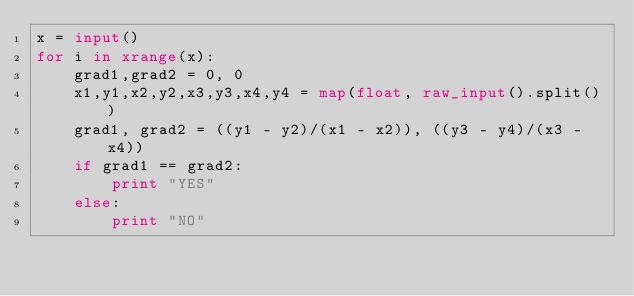Convert code to text. <code><loc_0><loc_0><loc_500><loc_500><_Python_>x = input()
for i in xrange(x):
	grad1,grad2 = 0, 0
	x1,y1,x2,y2,x3,y3,x4,y4 = map(float, raw_input().split())
	grad1, grad2 = ((y1 - y2)/(x1 - x2)), ((y3 - y4)/(x3 - x4))
	if grad1 == grad2:
		print "YES"
	else:
		print "NO"</code> 